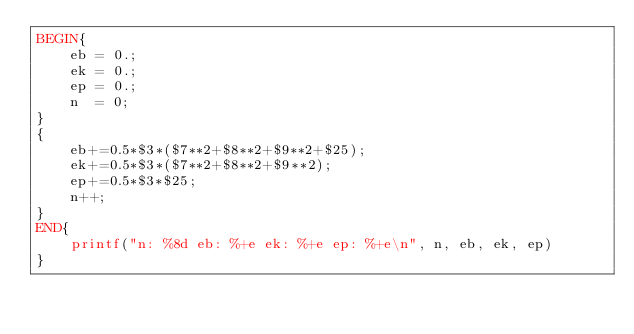<code> <loc_0><loc_0><loc_500><loc_500><_Awk_>BEGIN{
    eb = 0.;
    ek = 0.;
    ep = 0.;
    n  = 0;
}
{
    eb+=0.5*$3*($7**2+$8**2+$9**2+$25);
    ek+=0.5*$3*($7**2+$8**2+$9**2);
    ep+=0.5*$3*$25;
    n++;
}
END{
    printf("n: %8d eb: %+e ek: %+e ep: %+e\n", n, eb, ek, ep)
}
</code> 